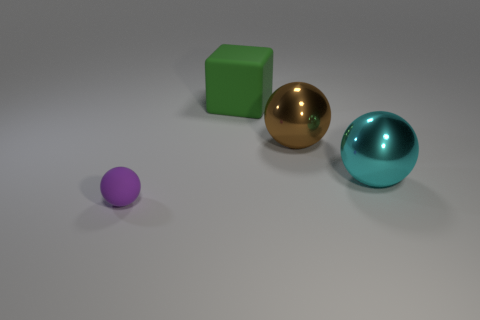Do the thing in front of the cyan shiny object and the brown thing have the same material? The materials appear to be different; the sphere in front of the cyan object has a reflective gold finish that suggests it is made of a metallic material, while the brown object has a matte finish, indicating it could be made of a different, possibly non-metallic material. 